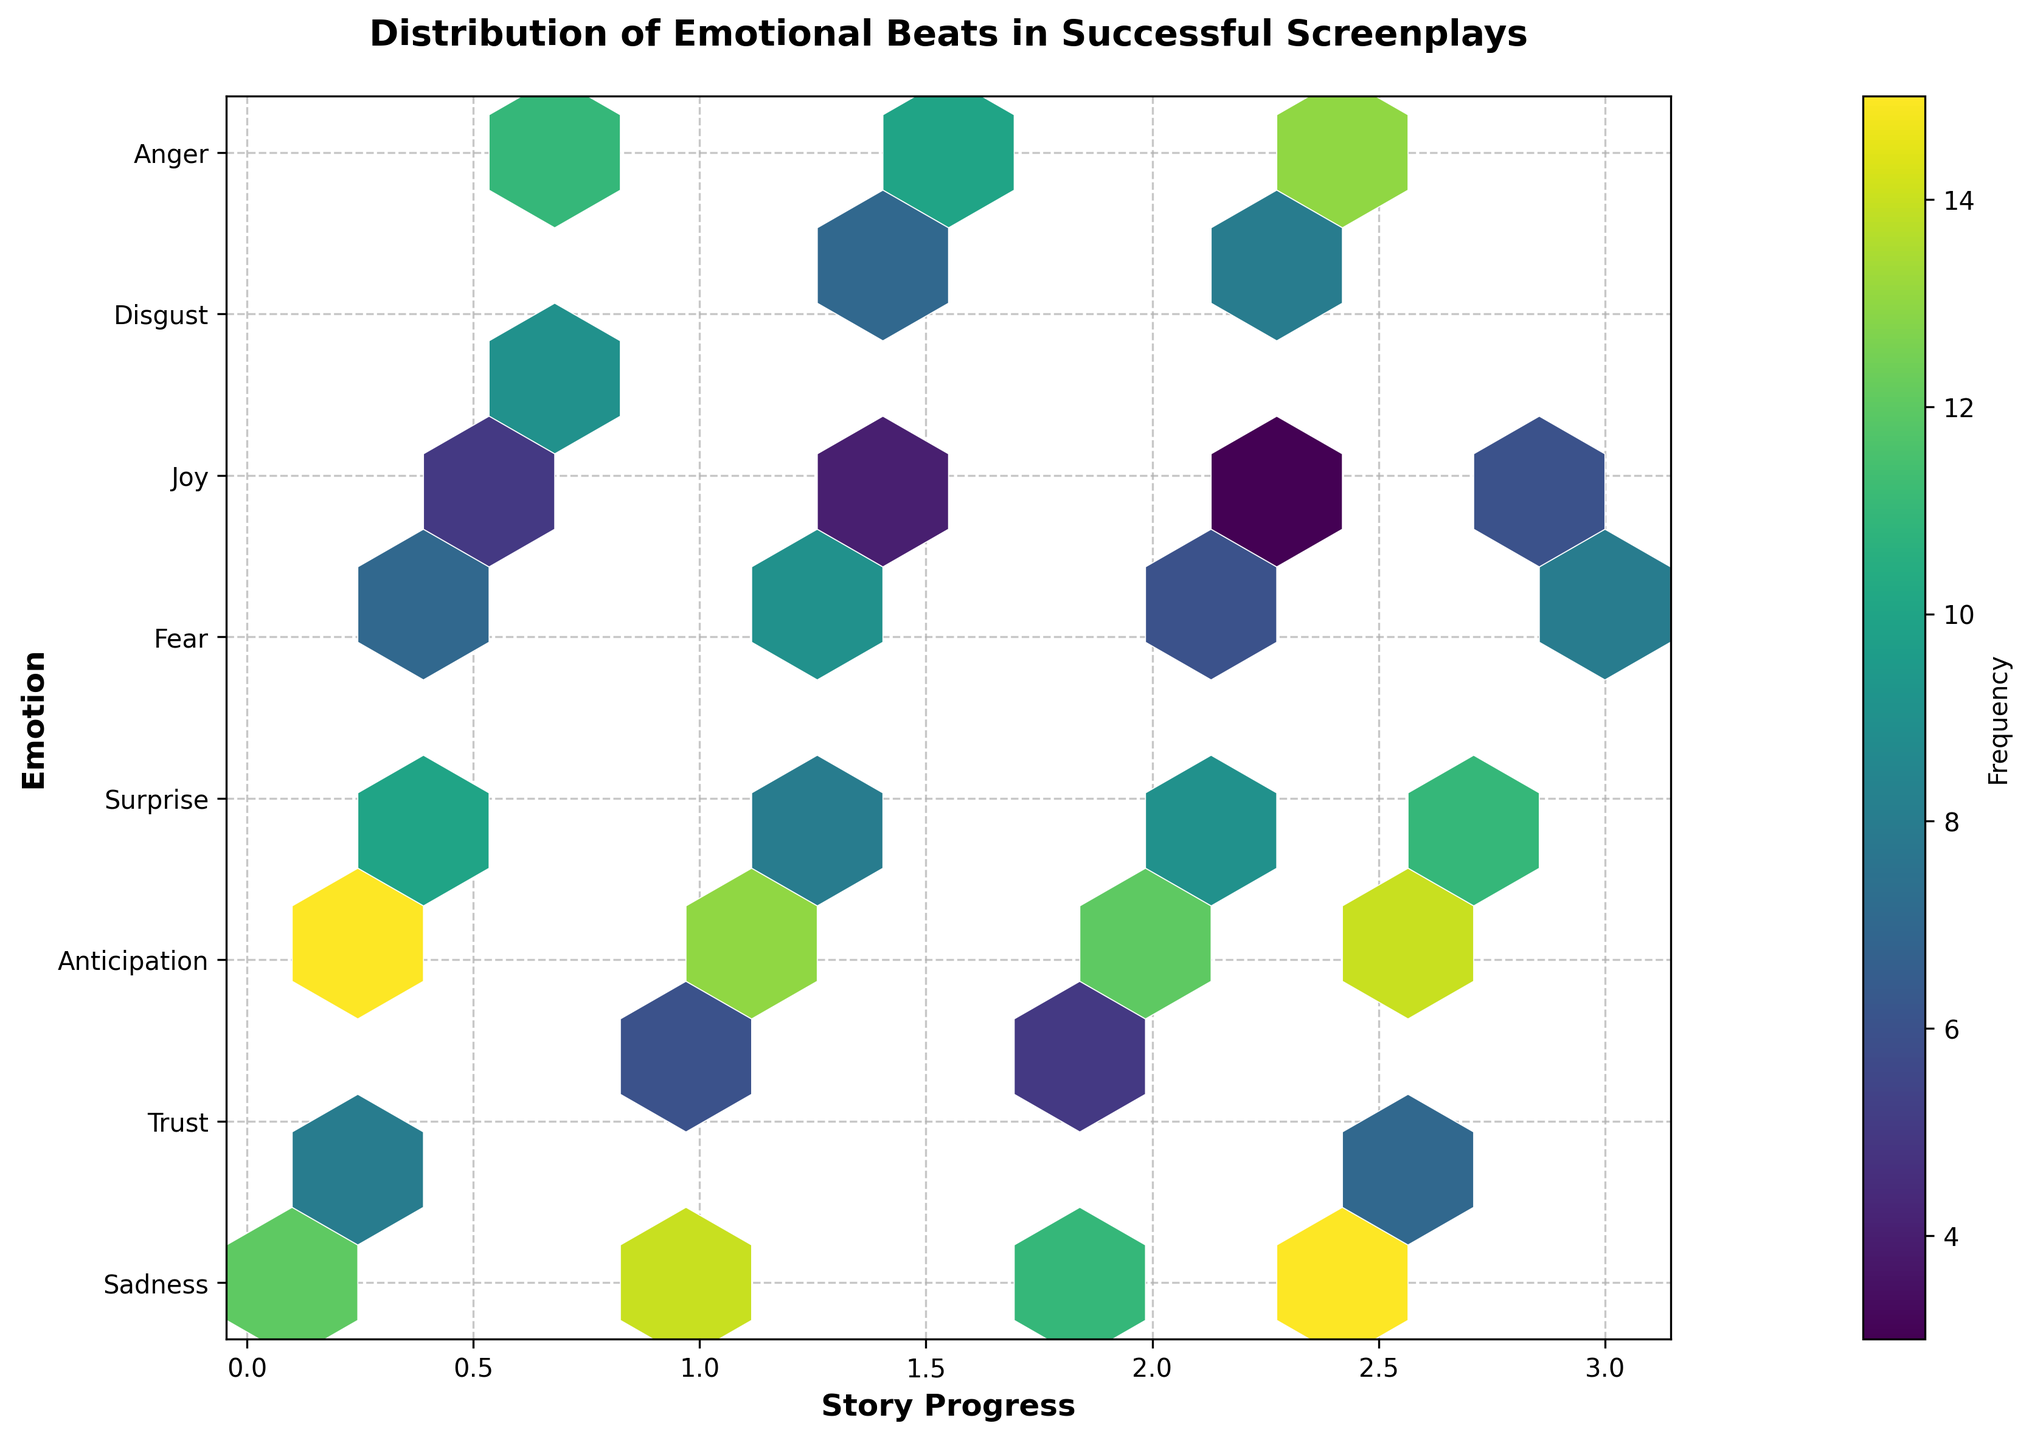what is the title of the figure? The title of the figure is displayed prominently at the top. It reads "Distribution of Emotional Beats in Successful Screenplays." By looking at the title, one immediately understands the figure’s focus.
Answer: Distribution of Emotional Beats in Successful Screenplays what are the labels for the x-axis and y-axis? The labels for the x-axis and y-axis are generally placed to help interpret the data. The x-axis label reads "Story Progress," and the y-axis label reads "Emotion."
Answer: Story Progress, Emotion which emotion has the highest frequency at the 0.3 story progress mark? By looking at the hexbin cells at the 0.3 mark on the x-axis, we find that "Fear" is associated with the highest frequency, as the hexbin cell there is the densest and darkest.
Answer: Fear comparing the emotions of trust and fear, which one has a higher frequency on average throughout the story? To determine the average frequency, we need to observe where the hexbin cells for "Trust" and "Fear" appear and visually estimate their densities. In general, "Fear" has hexbin cells with higher densities and larger frequencies compared to "Trust."
Answer: Fear which section of the story has the highest concentration of the emotion joy? By looking at the density and darkness of the hexbin cells along the emotion "Joy," the highest concentration appears around the story progress marks of 0.9 to 1.
Answer: 0.9 to 1 how does the frequency of surprise change from the beginning to the middle of the story? Observing the hexbin cells for "Surprise" from the lower x-axis values to the mid-range, we see a decrease in density. The frequency starts relatively high at the beginning (0.2) and gradually diminishes as we progress to the mid-story.
Answer: Decreases which emotion shows the least variability in frequency throughout the story? By comparing the consistency of hexbin cell densities across all emotions, "Disgust" shows the least variability as its cells maintain relatively low and consistent frequencies across all story progress points.
Answer: Disgust what is the general trend of the emotion anticipation from the midpoint to the end of the story? To identify the trend, observe that "Anticipation" starts with medium frequency values around the midpoint but increases significantly in frequency towards the end.
Answer: Increases are there any emotions that peak more than once in frequency throughout the story? By scanning across the y-axis for multiple high-density hexbin cells, "Joy" and "Fear" are observed to have multiple peaks at different points along the x-axis.
Answer: Joy, Fear between anger and sadness, which emotion peaks later in the story? By comparing the highest-density hexbin cells for "Anger" and "Sadness," we find that "Anger" peaks around the 2.9 mark, while "Sadness" peaks earlier around the 2.
Answer: Anger 